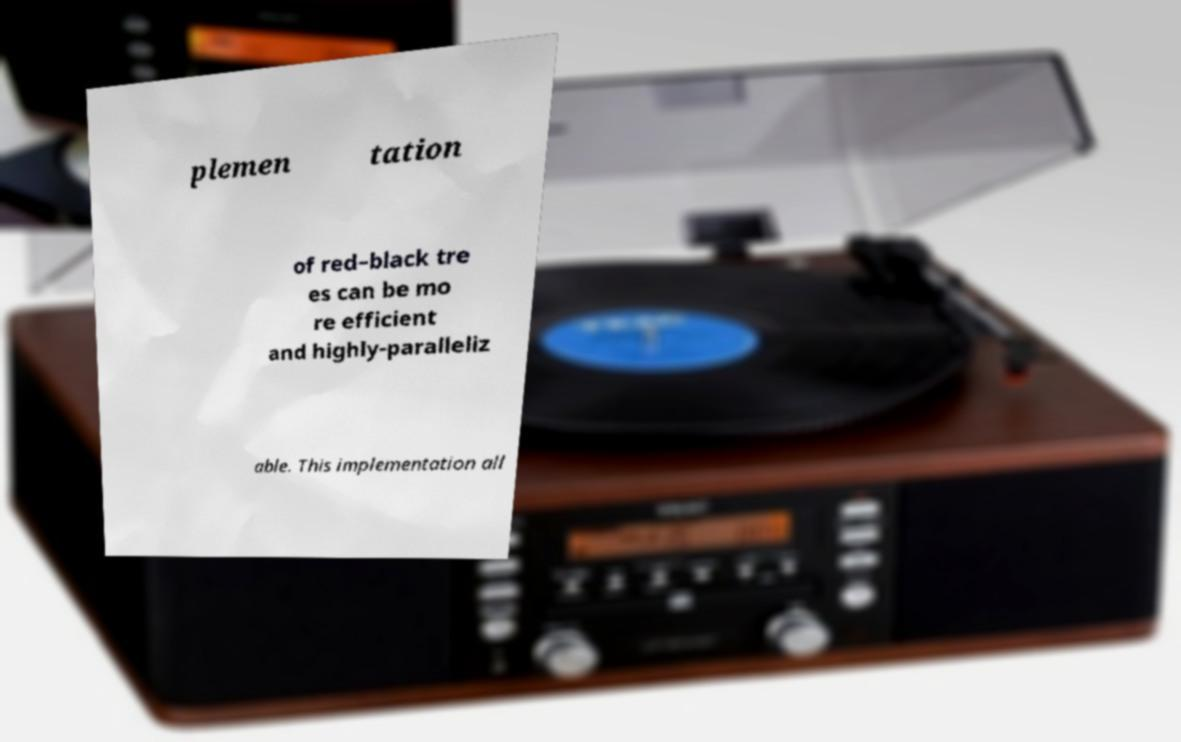There's text embedded in this image that I need extracted. Can you transcribe it verbatim? plemen tation of red–black tre es can be mo re efficient and highly-paralleliz able. This implementation all 